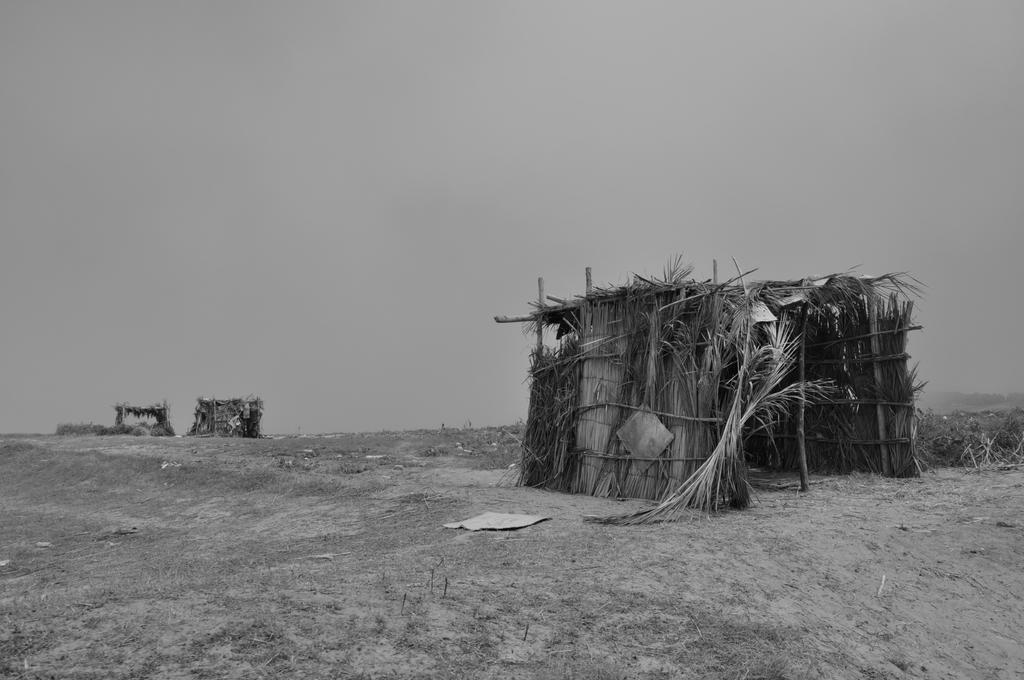Can you describe this image briefly? This is a black and white image, in this image there is a land and huts. 